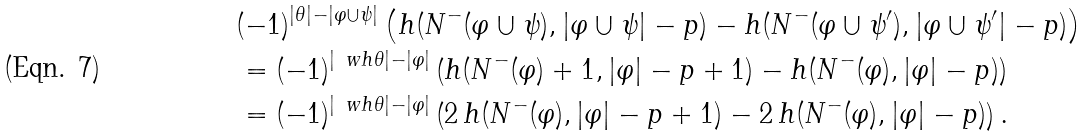Convert formula to latex. <formula><loc_0><loc_0><loc_500><loc_500>& ( - 1 ) ^ { | \theta | - | \varphi \cup \psi | } \left ( h ( N ^ { - } ( \varphi \cup \psi ) , | \varphi \cup \psi | - p ) - h ( N ^ { - } ( \varphi \cup \psi ^ { \prime } ) , | \varphi \cup \psi ^ { \prime } | - p ) \right ) \\ & = ( - 1 ) ^ { | \ w h \theta | - | \varphi | } \left ( h ( N ^ { - } ( \varphi ) + 1 , | \varphi | - p + 1 ) - h ( N ^ { - } ( \varphi ) , | \varphi | - p ) \right ) \\ & = ( - 1 ) ^ { | \ w h \theta | - | \varphi | } \left ( 2 \, h ( N ^ { - } ( \varphi ) , | \varphi | - p + 1 ) - 2 \, h ( N ^ { - } ( \varphi ) , | \varphi | - p ) \right ) .</formula> 